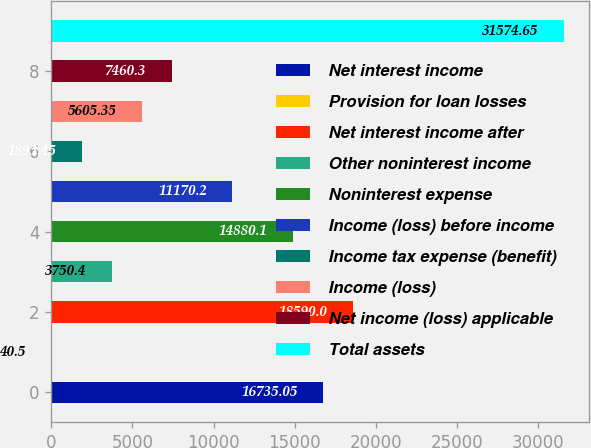<chart> <loc_0><loc_0><loc_500><loc_500><bar_chart><fcel>Net interest income<fcel>Provision for loan losses<fcel>Net interest income after<fcel>Other noninterest income<fcel>Noninterest expense<fcel>Income (loss) before income<fcel>Income tax expense (benefit)<fcel>Income (loss)<fcel>Net income (loss) applicable<fcel>Total assets<nl><fcel>16735<fcel>40.5<fcel>18590<fcel>3750.4<fcel>14880.1<fcel>11170.2<fcel>1895.45<fcel>5605.35<fcel>7460.3<fcel>31574.7<nl></chart> 